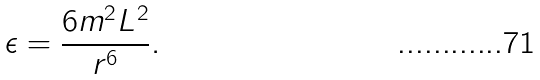Convert formula to latex. <formula><loc_0><loc_0><loc_500><loc_500>\epsilon = \frac { 6 m ^ { 2 } L ^ { 2 } } { r ^ { 6 } } .</formula> 